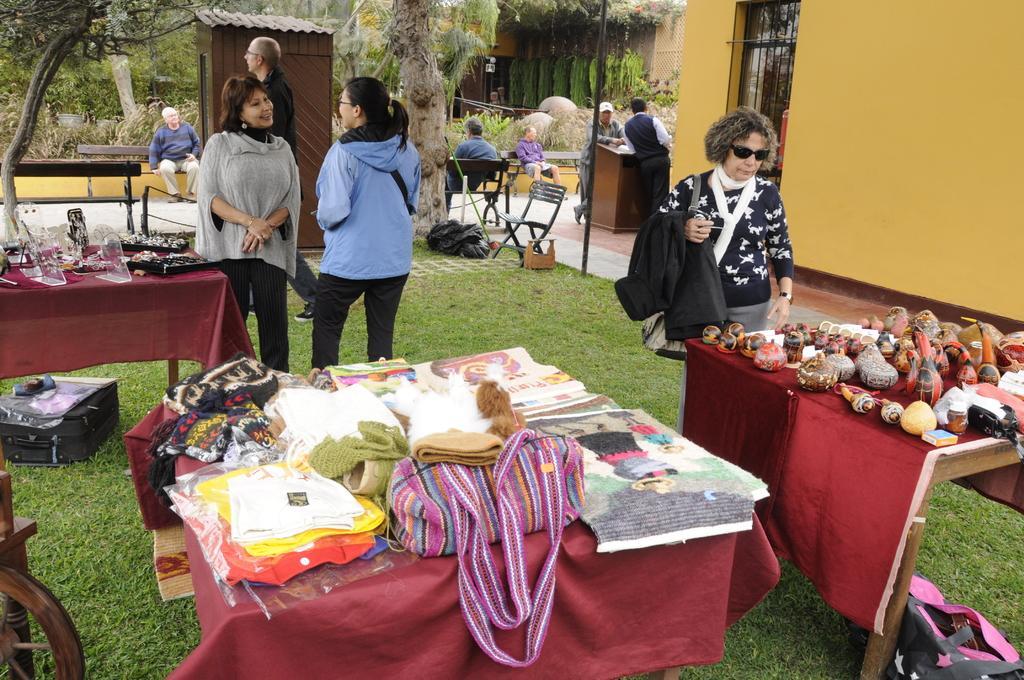In one or two sentences, can you explain what this image depicts? In this picture there are a group of women standing, smiling, and speaking with each other. In the background there are few men sitting on the bench, there are trees, buildings, window, wall and some tables with some toys, clothes and jewelry displayed and there are bags and some chairs 